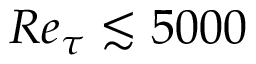Convert formula to latex. <formula><loc_0><loc_0><loc_500><loc_500>R e _ { \tau } \lesssim 5 0 0 0</formula> 